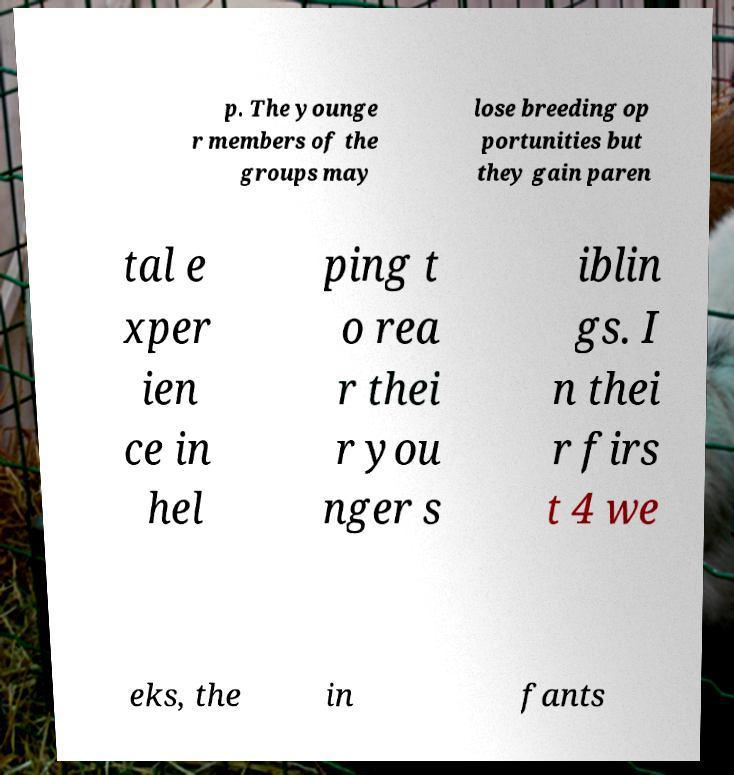Could you extract and type out the text from this image? p. The younge r members of the groups may lose breeding op portunities but they gain paren tal e xper ien ce in hel ping t o rea r thei r you nger s iblin gs. I n thei r firs t 4 we eks, the in fants 